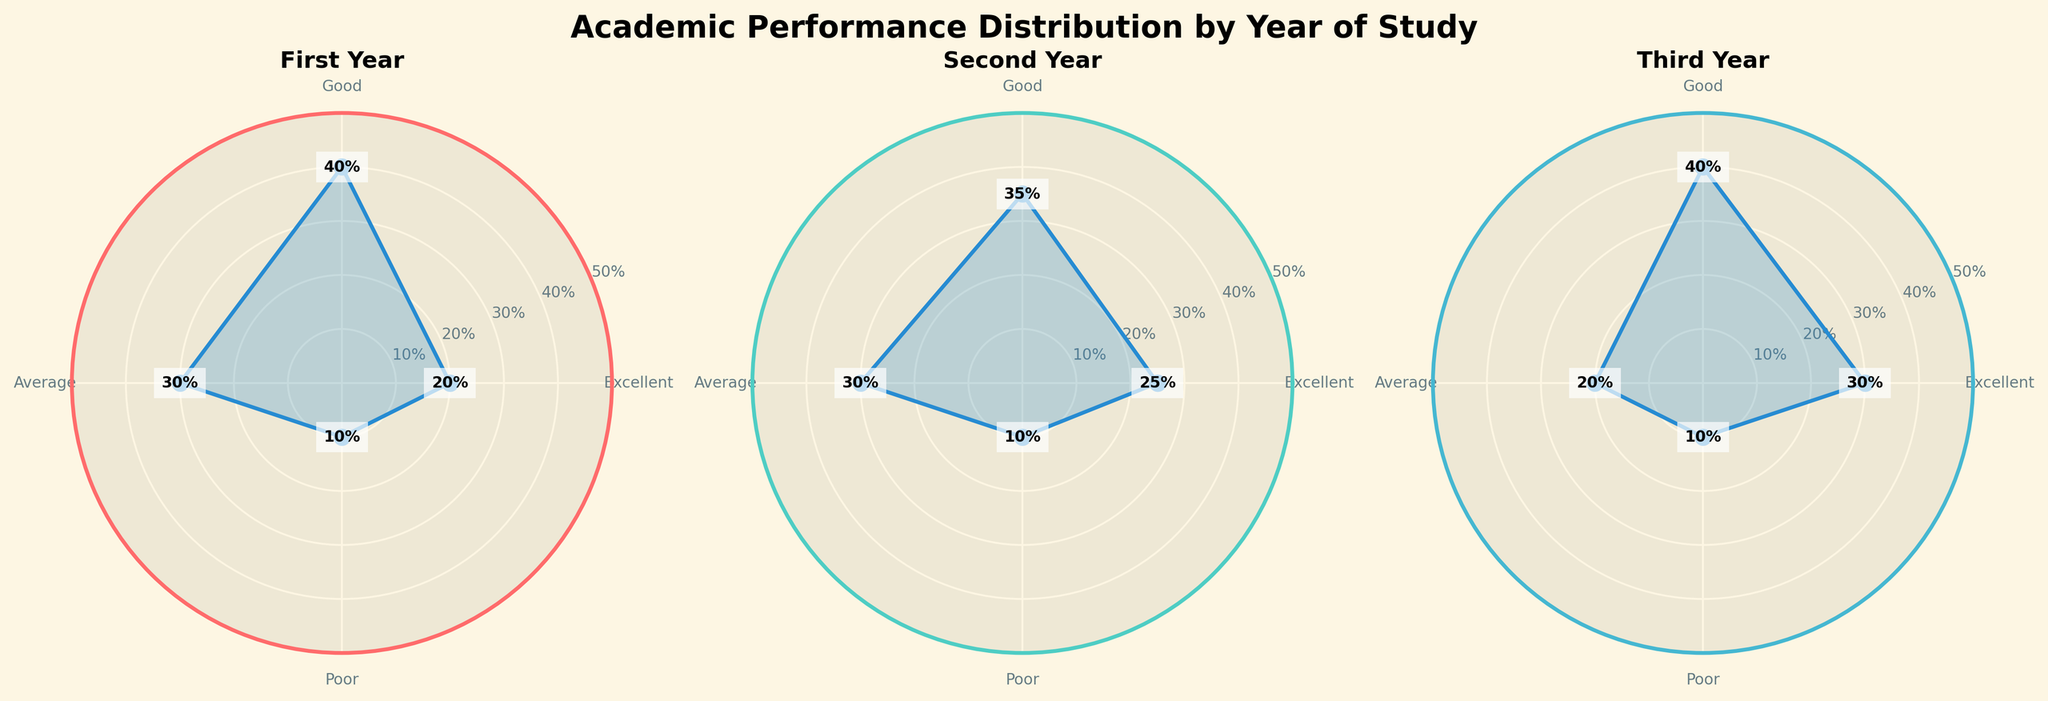What is the title of the figure? The title of the figure is typically provided at the top, summarizing the content. In this case, it is clearly mentioned as 'Academic Performance Distribution by Year of Study'.
Answer: Academic Performance Distribution by Year of Study How many categories of performance are shown in the figure? By looking at the labels on the chart, we can see that there are four performance categories indicated: Excellent, Good, Average, and Poor.
Answer: Four In which year is the percentage of students with Excellent performance the highest? By comparing the sections labeled 'Excellent' in each year's chart, we see that the Third Year has the highest percentage of students with Excellent performance at 30%.
Answer: Third Year What is the combined percentage of students with Poor performance across all years? We sum the percentages of students with Poor performance for each year: 10% (First Year) + 10% (Second Year) + 10% (Third Year) = 30%.
Answer: 30% Which year has the smallest percentage of students performing averagely? By comparing the 'Average' sections in each year's chart, we see that the Third Year has the smallest percentage of students with Average performance at 20%.
Answer: Third Year How much higher is the percentage of Excellent performance in the Second Year compared to the First Year? We subtract the percentage of Excellent performance in the First Year from the Second Year: 25% (Second Year) - 20% (First Year) = 5%.
Answer: 5% What trend do you observe in the percentage of students with Excellent performance as they progress from the First Year to the Third Year? The chart shows an increasing trend: 20% (First Year), 25% (Second Year), 30% (Third Year). The percentage of students with Excellent performance increases as they progress through the years.
Answer: Increasing Which year shows an equal distribution of students in Good and Average categories? By inspecting the 'Good' and 'Average' sections in each year's chart, we notice that the First Year has an equal distribution with 40% in Good and 30% in Average categories; they do not show equality. However, re-inspection indicates all years maintain a similar difference.
Answer: None What category has the largest percentage in the Third Year? By inspecting the Third Year's chart, the 'Good' category has the largest percentage of 40%.
Answer: Good Is there a year where the percentage of students in Poor performance is different from the others? By looking at the 'Poor' sections in each year's chart, we find that the percentage of students with Poor performance remains consistent at 10% for all three years, indicating no difference.
Answer: No 